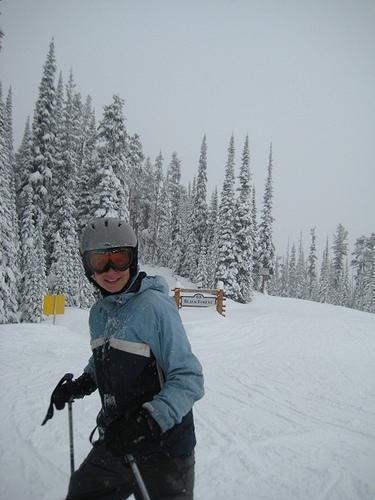How many people are pictured?
Give a very brief answer. 1. 